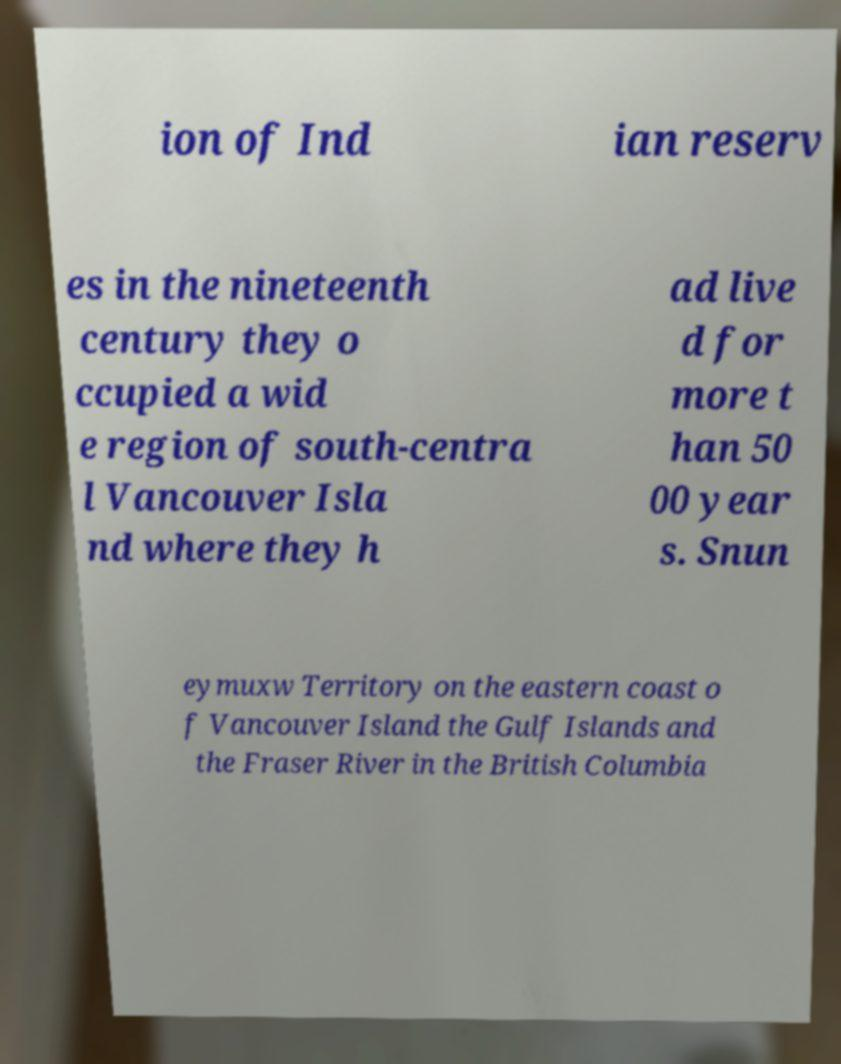Please read and relay the text visible in this image. What does it say? ion of Ind ian reserv es in the nineteenth century they o ccupied a wid e region of south-centra l Vancouver Isla nd where they h ad live d for more t han 50 00 year s. Snun eymuxw Territory on the eastern coast o f Vancouver Island the Gulf Islands and the Fraser River in the British Columbia 